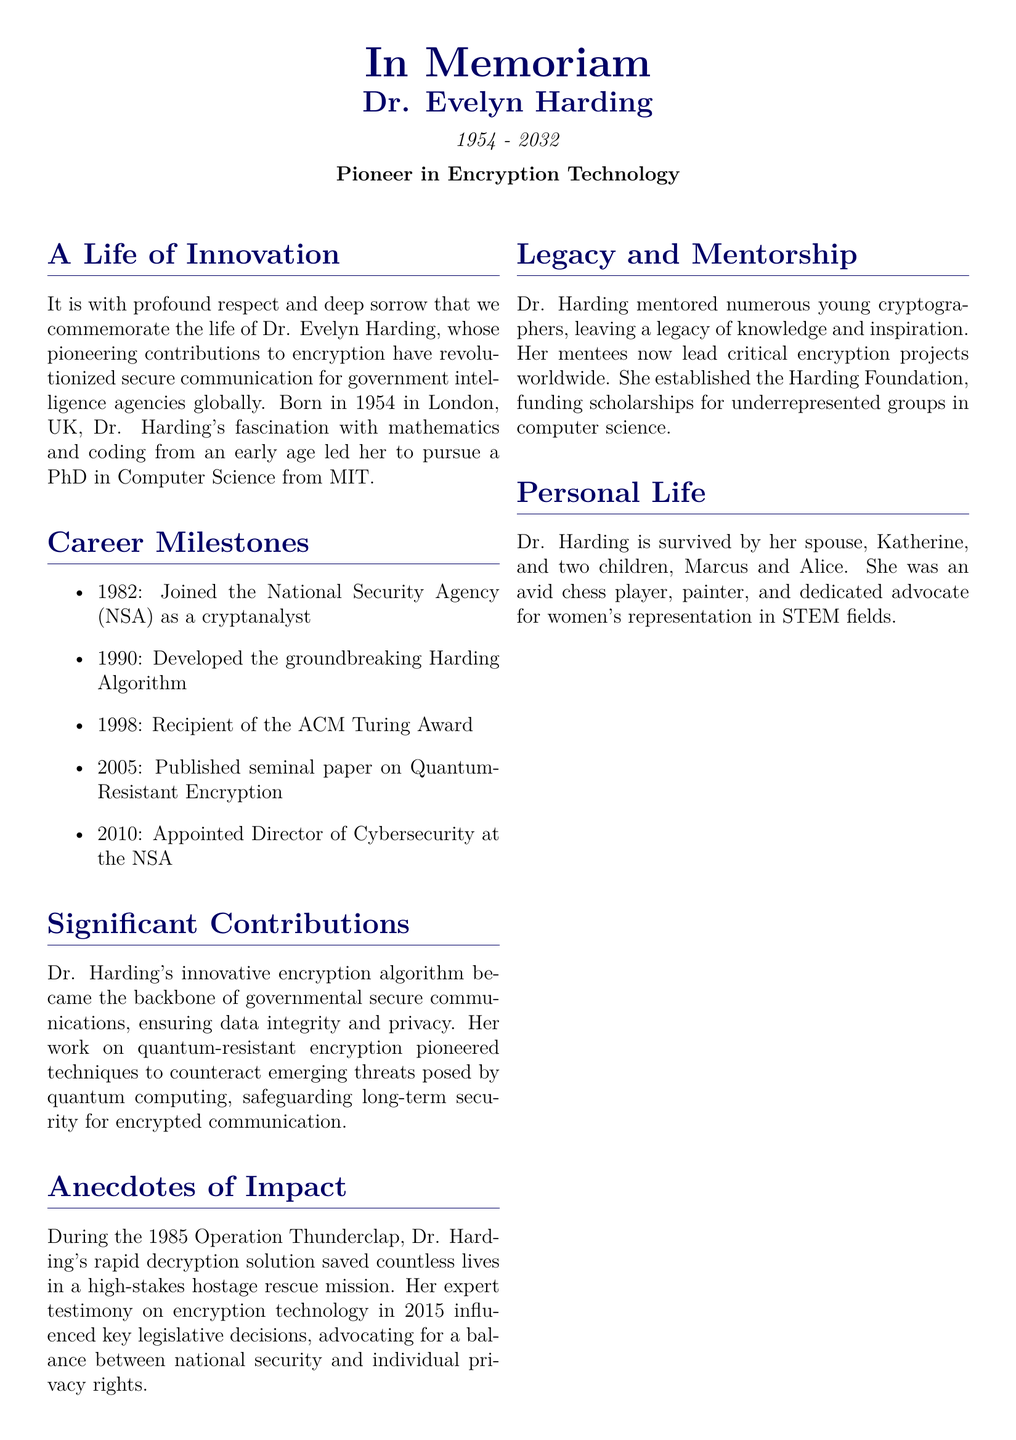What year was Dr. Evelyn Harding born? The document states that Dr. Evelyn Harding was born in 1954.
Answer: 1954 What award did Dr. Harding receive in 1998? According to the document, she was the recipient of the ACM Turing Award in 1998.
Answer: ACM Turing Award What is the name of the algorithm developed by Dr. Harding? The document refers to the algorithm she developed as the Harding Algorithm.
Answer: Harding Algorithm In which year was Dr. Harding appointed Director of Cybersecurity at the NSA? The document mentions that she was appointed in 2010.
Answer: 2010 What was Dr. Harding's role in Operation Thunderclap? The document indicates that Dr. Harding provided a rapid decryption solution during this operation.
Answer: rapid decryption solution What is one of Dr. Harding's personal interests mentioned in the obituary? The document states that she was an avid chess player, among other interests.
Answer: chess player What organization did Dr. Harding establish to fund scholarships? The document mentions the Harding Foundation as the organization she established.
Answer: Harding Foundation What significant contribution did Dr. Harding make regarding quantum-resistant encryption? The document notes that her work pioneered techniques to counteract threats posed by quantum computing.
Answer: counteract threats posed by quantum computing What was Dr. Harding's quote regarding encryption? The document includes her quote about encryption being about safeguarding trust in the digital world.
Answer: "Encryption is not just about protecting data; it's about safeguarding the very foundations of trust in our digital world." 